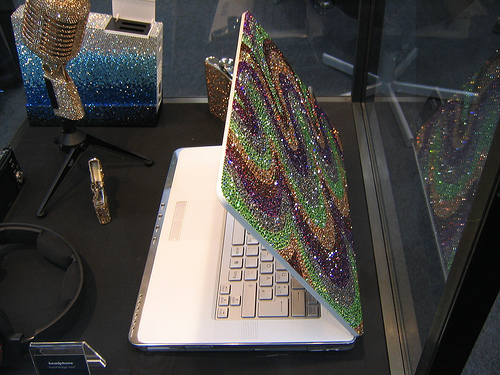<image>
Is the microphone to the right of the computer? No. The microphone is not to the right of the computer. The horizontal positioning shows a different relationship. 